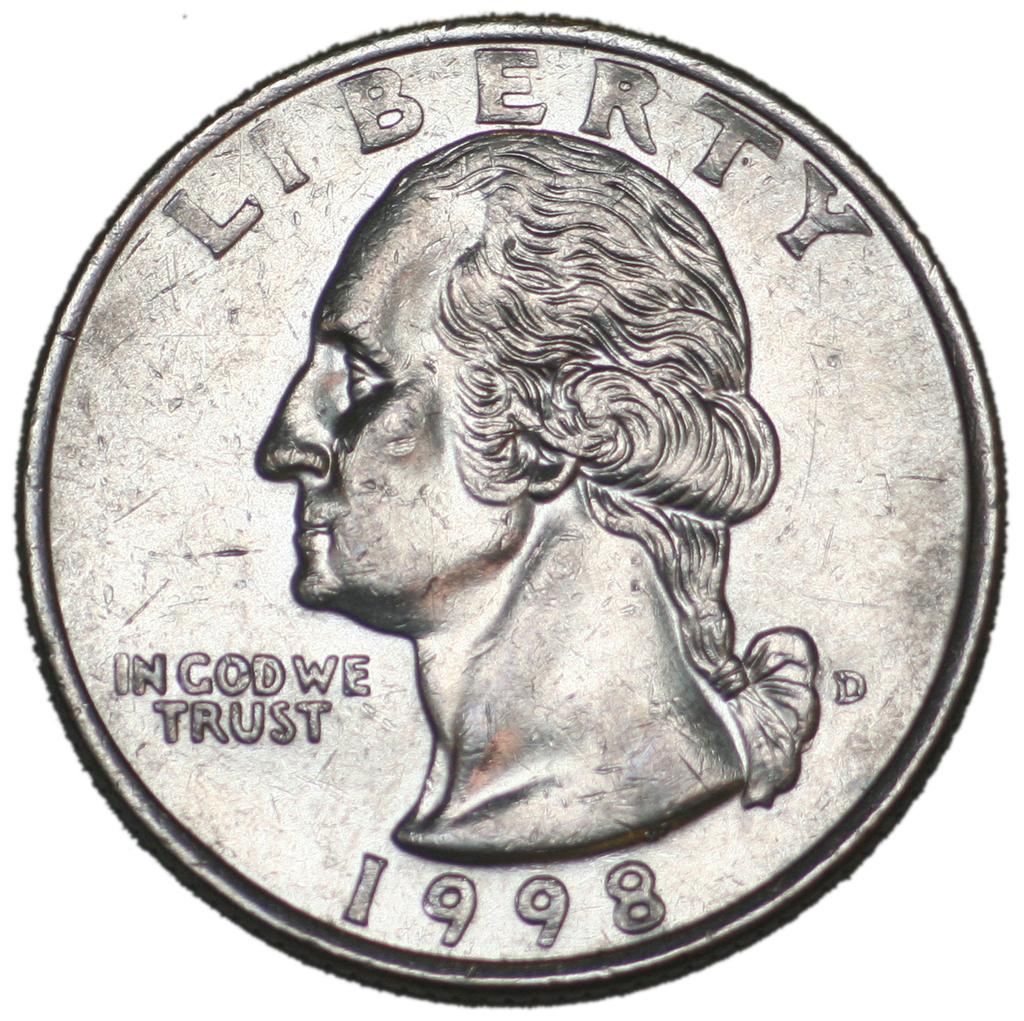<image>
Offer a succinct explanation of the picture presented. A quarter that says in God we trust and was made in 1998. 